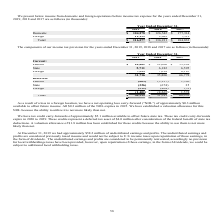According to Manhattan Associates's financial document, What is the federal tax in 2019? According to the financial document, 18,682 (in thousands). The relevant text states: "Federal $ 18,682 $ 22,606 $ 53,998..." Also, What is the foreign tax in 2019? According to the financial document, 7,323 (in thousands). The relevant text states: "Foreign 7,323 7,018 6,185..." Also, What is the amount of undistributed earnings and profits in 2019? According to the financial document, $58.2 million. The relevant text states: "At December 31, 2019 we had approximately $58.2 million of undistributed earnings and profits. The undistributed earnings and profits are considered previou..." Additionally, Which year had the highest current federal tax? According to the financial document, 2017. The relevant text states: "2019 2018 2017..." Also, can you calculate: What is the change in current federal taxes between 2018 and 2019? Based on the calculation: 18,682-22,606, the result is -3924 (in thousands). This is based on the information: "Federal $ 18,682 $ 22,606 $ 53,998 Federal $ 18,682 $ 22,606 $ 53,998..." The key data points involved are: 18,682, 22,606. Also, can you calculate: What is the change in tax payable between 2017 and 2018? Based on the calculation: 68,352-31,541, the result is 36811 (in thousands). This is based on the information: "Total $ 30,315 $ 31,541 $ 68,352 Total $ 30,315 $ 31,541 $ 68,352..." The key data points involved are: 31,541, 68,352. 